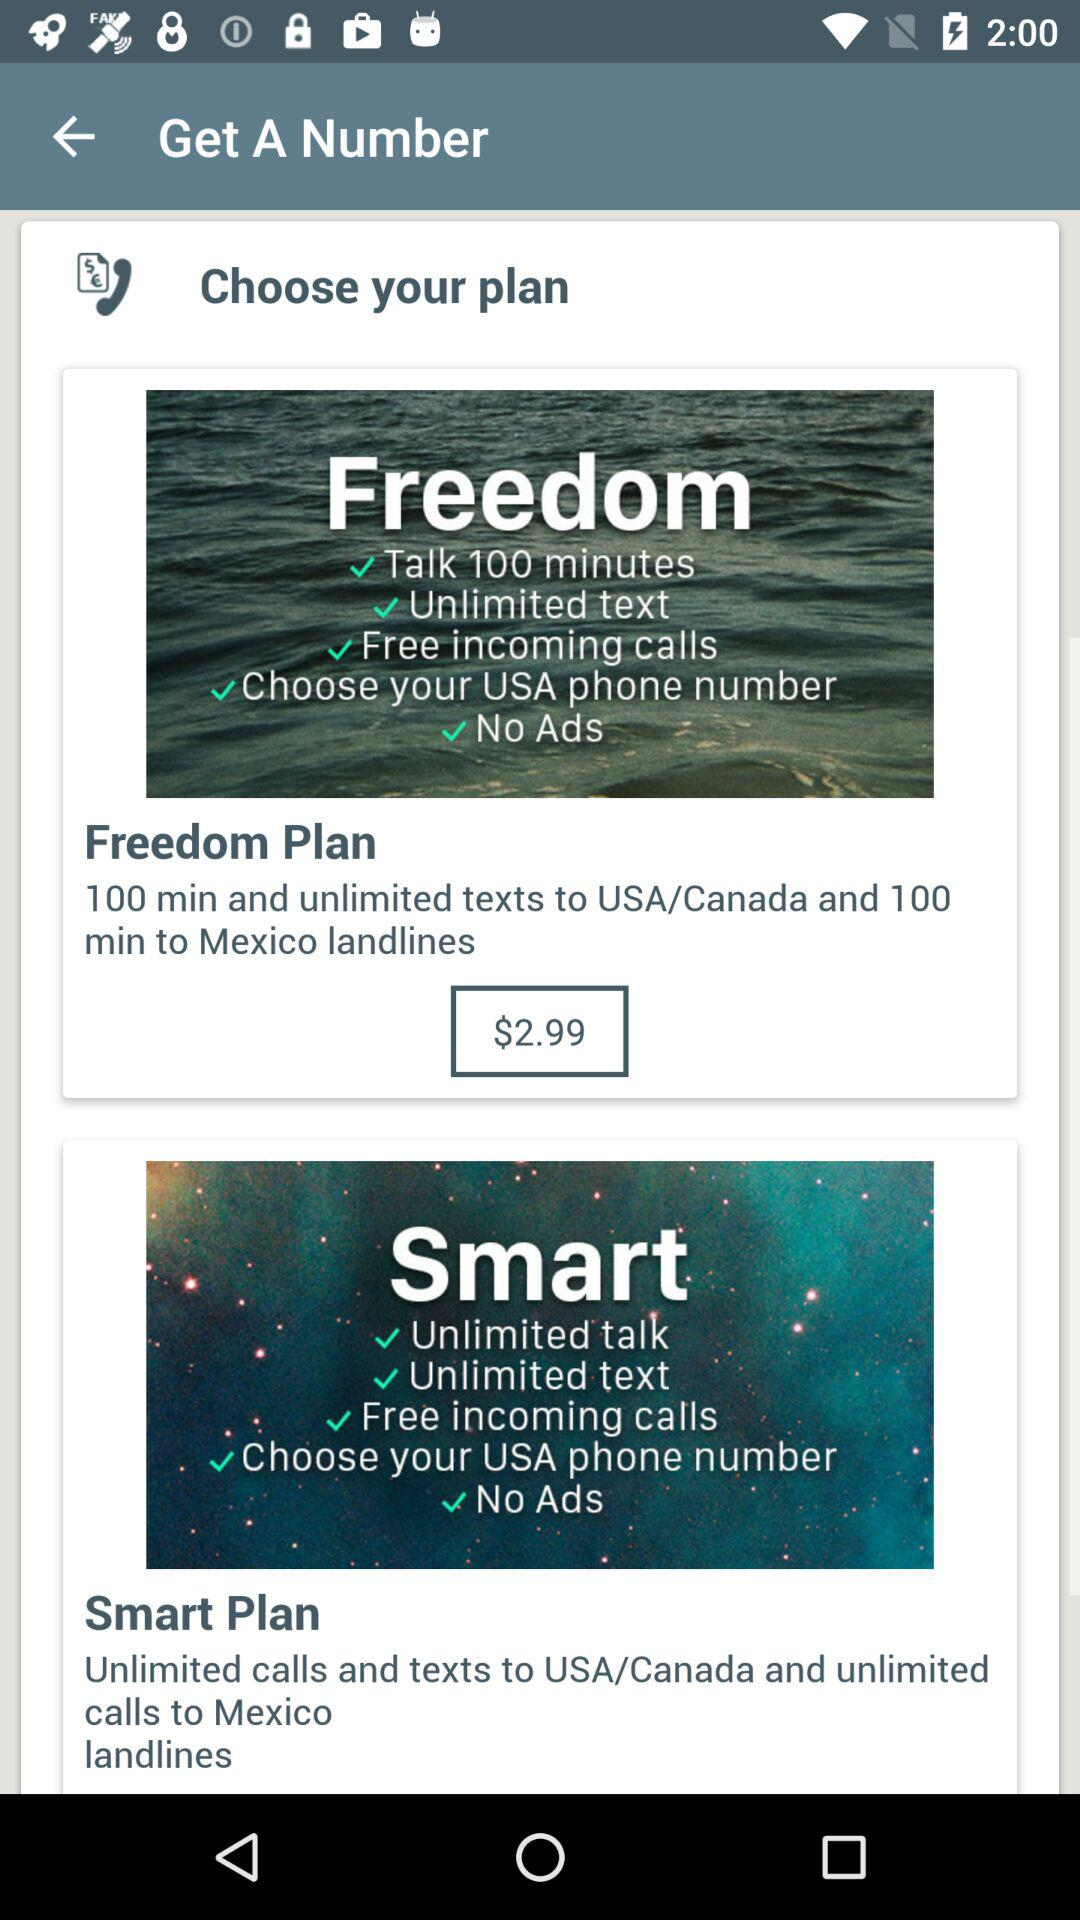What's the cost of "Freedom Plan"? The cost is $2.99. 